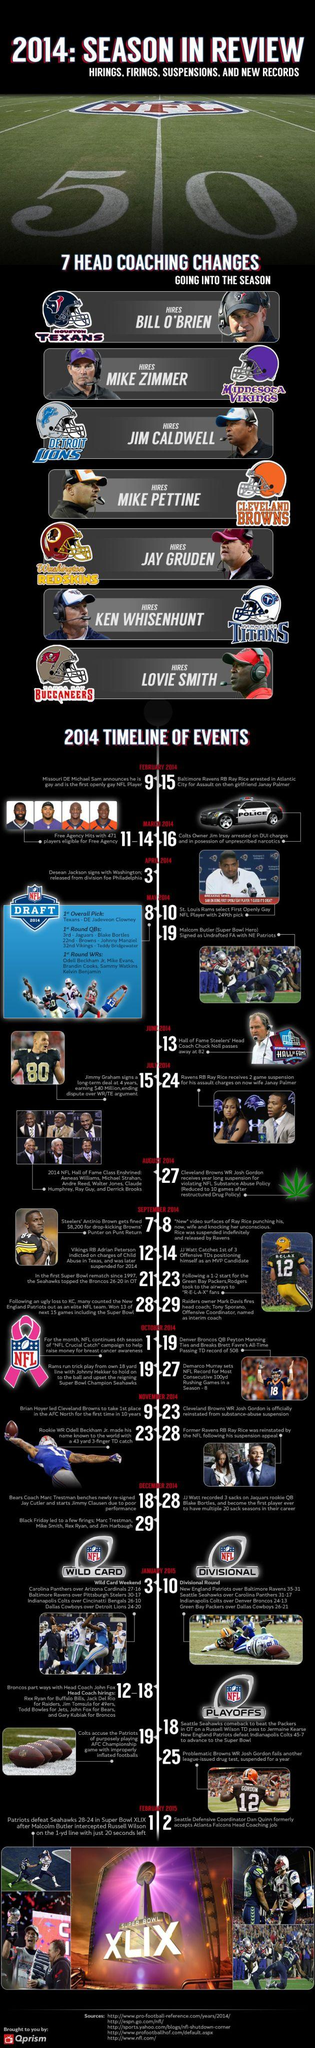Indicate a few pertinent items in this graphic. The Washington Redskins hired Jay Gruden as their head coach in the 2014 NFL season. In the 2014 NFL season, MIKE ZIMMER served as the head coach of the Minnesota Vikings. The Super Bowl XLIX game was played on February 1, 2015. 